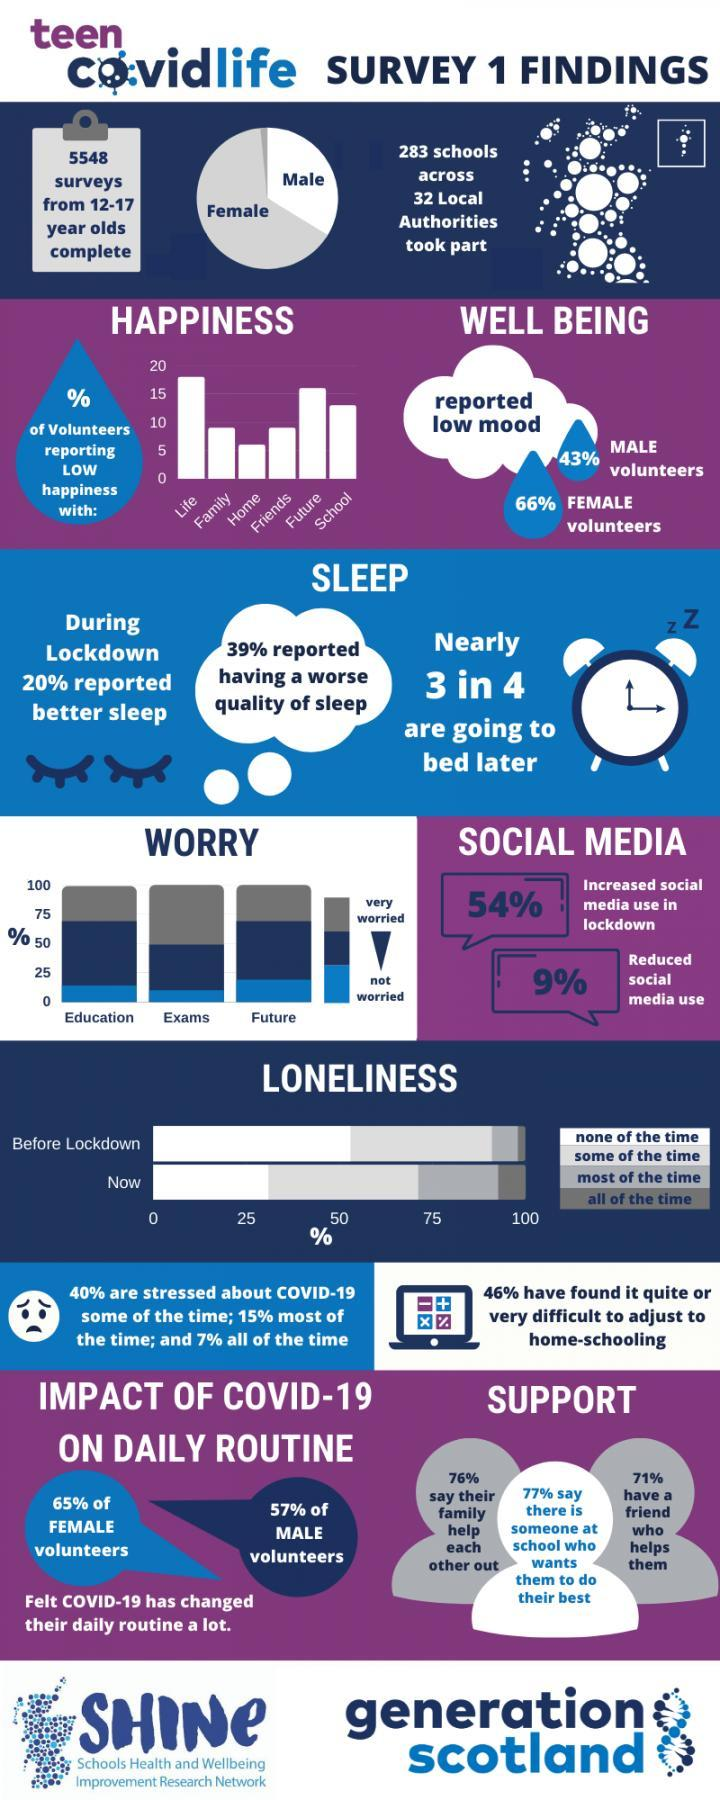What was most of the respondents 'very worried' about?
Answer the question with a short phrase. Exams What were the volunteers  least unhappy about? Home What percentage of students found it difficult to adjust to homeschooling? 46% What 'percentage' of respondents were late to bed? 75% What percentage of respondents decreased the usage of social media during lockdown? 9% How many 12 to 17 year olds were surveyed? 5548 What percent of respondents had a worse quality of sleep during lockdown? 39% What percentage of respondents are stressed out about covid-19 all the time? 7% What percentage of respondents had their family to support them? 76% To which gender did majority of the surveyed belong? Female What percent of female volunteers felt covid-19 changed their daily routine a lot? 65% What percentage of respondents had a friend to support them? 71% What was most of the respondents 'not worried' about? Future What percent of respondents had better sleep during the lockdown? 20% What was majority of the volunteers unhappy with? Life 